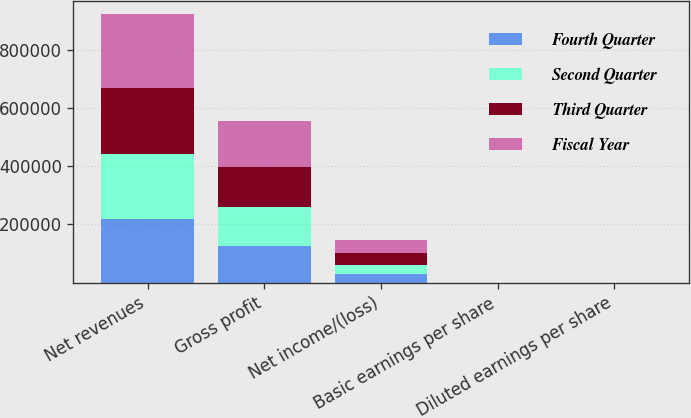Convert chart. <chart><loc_0><loc_0><loc_500><loc_500><stacked_bar_chart><ecel><fcel>Net revenues<fcel>Gross profit<fcel>Net income/(loss)<fcel>Basic earnings per share<fcel>Diluted earnings per share<nl><fcel>Fourth Quarter<fcel>217931<fcel>127127<fcel>28027<fcel>0.37<fcel>0.36<nl><fcel>Second Quarter<fcel>222980<fcel>131024<fcel>33853<fcel>0.45<fcel>0.44<nl><fcel>Third Quarter<fcel>227865<fcel>138943<fcel>39198<fcel>0.52<fcel>0.51<nl><fcel>Fiscal Year<fcel>251959<fcel>156708<fcel>45370<fcel>0.6<fcel>0.59<nl></chart> 